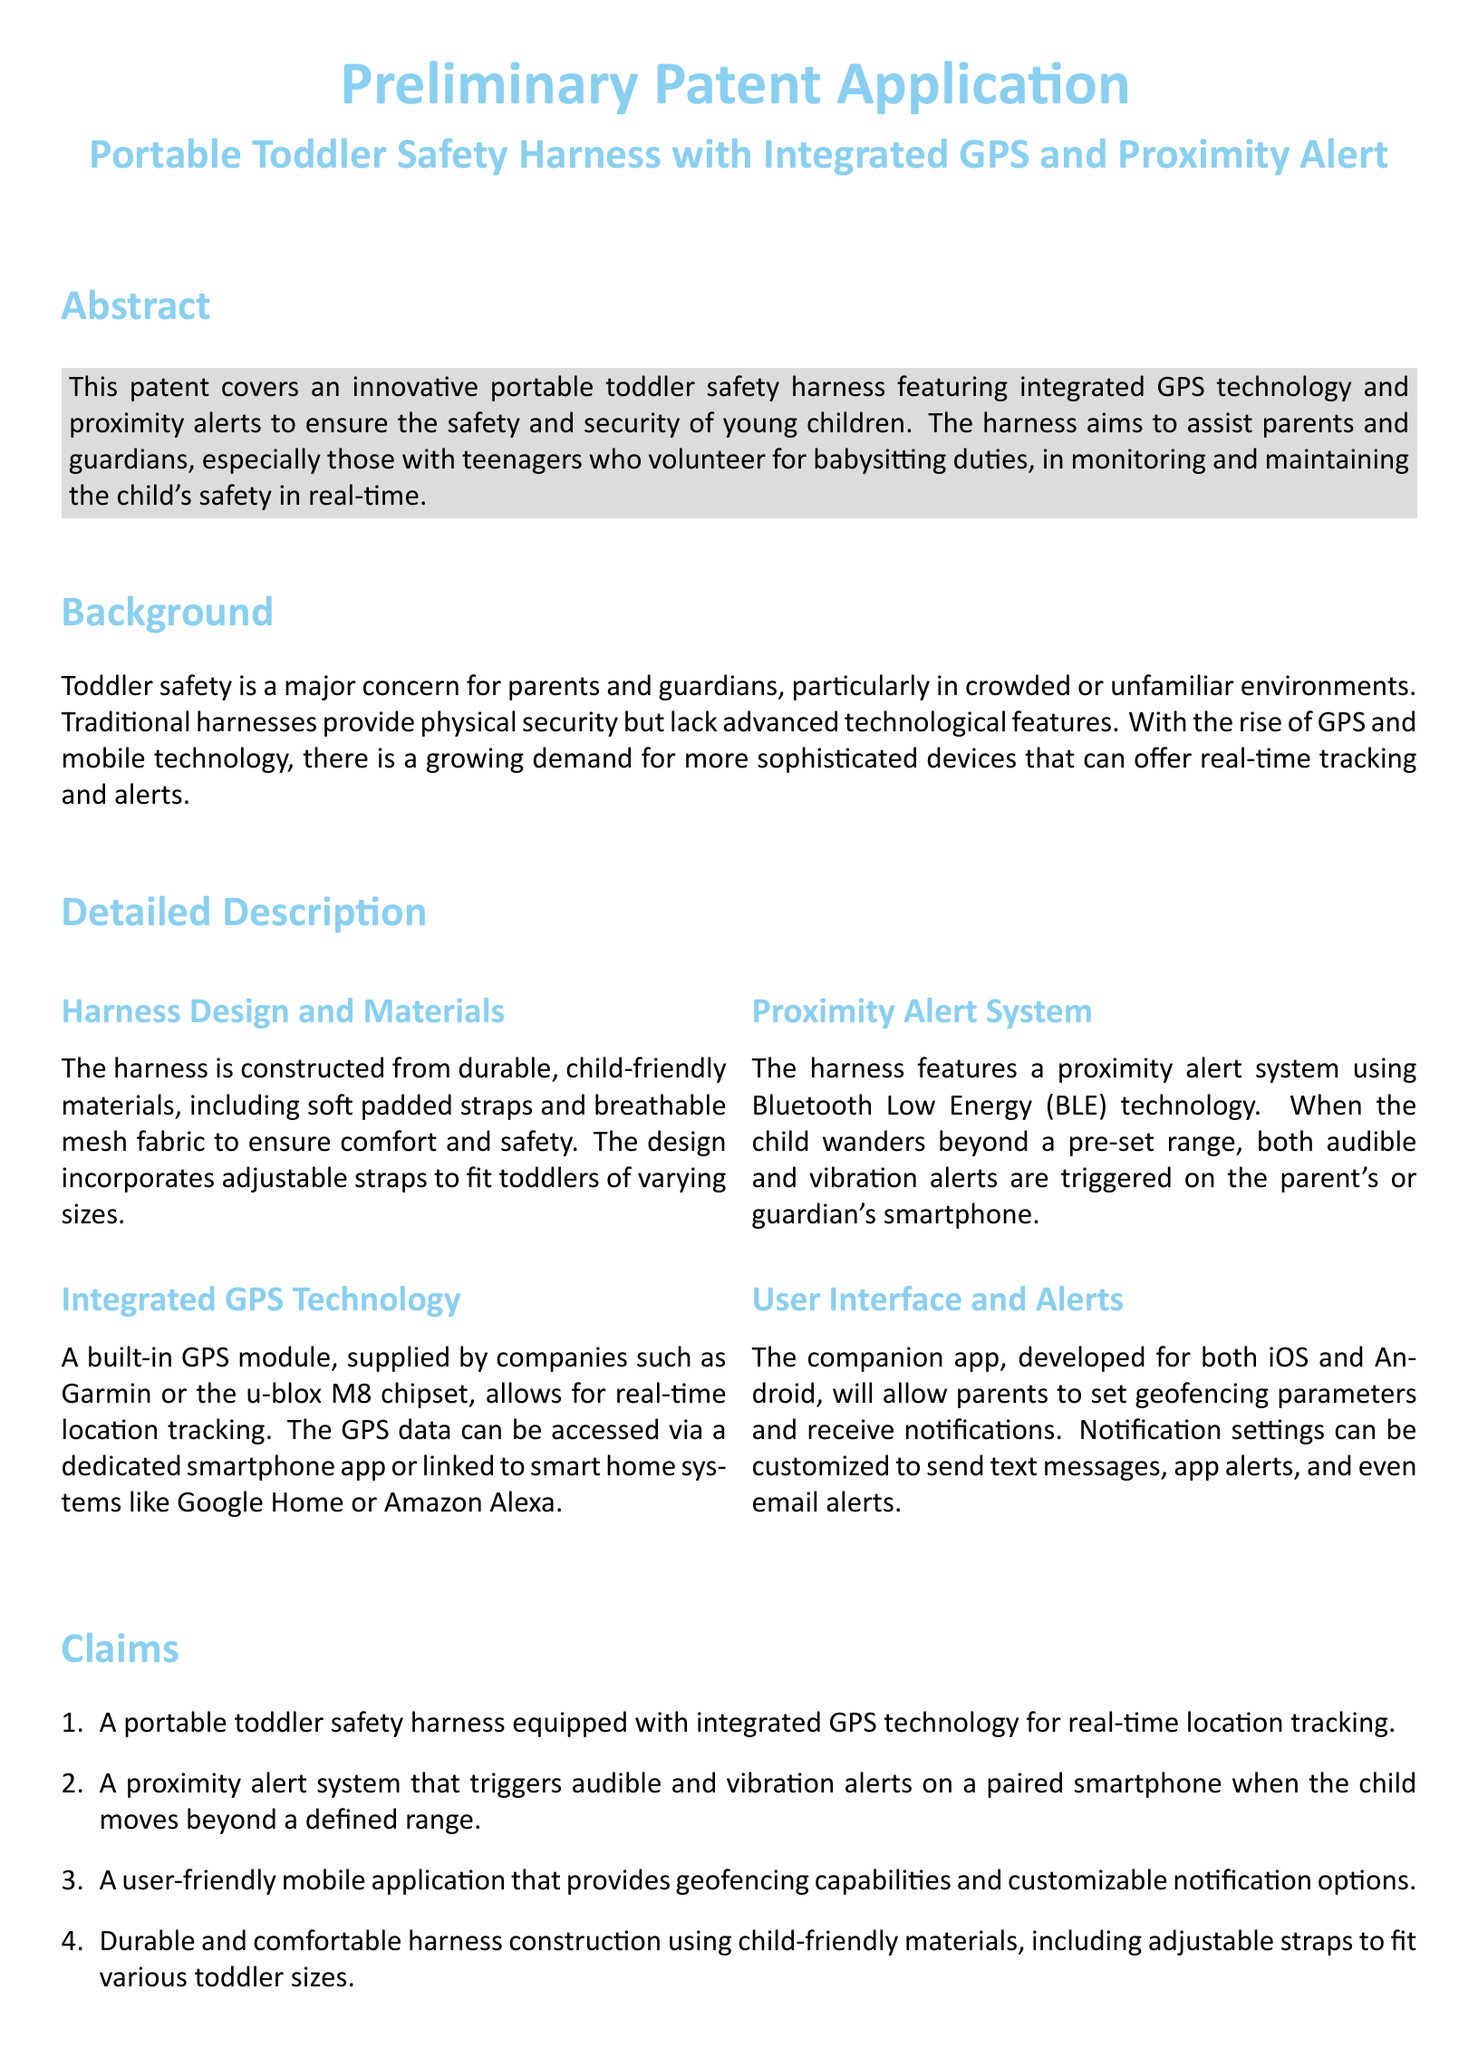What is the main purpose of the patent? The patent aims to ensure the safety and security of young children through a portable safety harness with GPS and alerts.
Answer: Ensure safety and security What technology is integrated into the harness? The harness features integrated GPS technology for real-time location tracking.
Answer: GPS technology What triggers the proximity alert? The proximity alert is triggered when the child wanders beyond a pre-set range.
Answer: Pre-set range What materials are used for the harness? The harness is constructed from durable, child-friendly materials, including soft padded straps and breathable mesh fabric.
Answer: Soft padded straps and breathable mesh fabric How many claims are included in the patent? The patent includes four claims regarding the features of the harness.
Answer: Four claims What is the companion app developed for? The companion app is developed to allow parents to set geofencing parameters and receive notifications.
Answer: Set geofencing parameters and receive notifications Which companies supply the GPS module? Companies like Garmin or the u-blox M8 chipset supply the GPS module.
Answer: Garmin, u-blox M8 What platforms is the mobile application available on? The mobile application is available for both iOS and Android platforms.
Answer: iOS and Android What type of alerts does the proximity alert system include? The proximity alert system includes audible and vibration alerts.
Answer: Audible and vibration alerts 